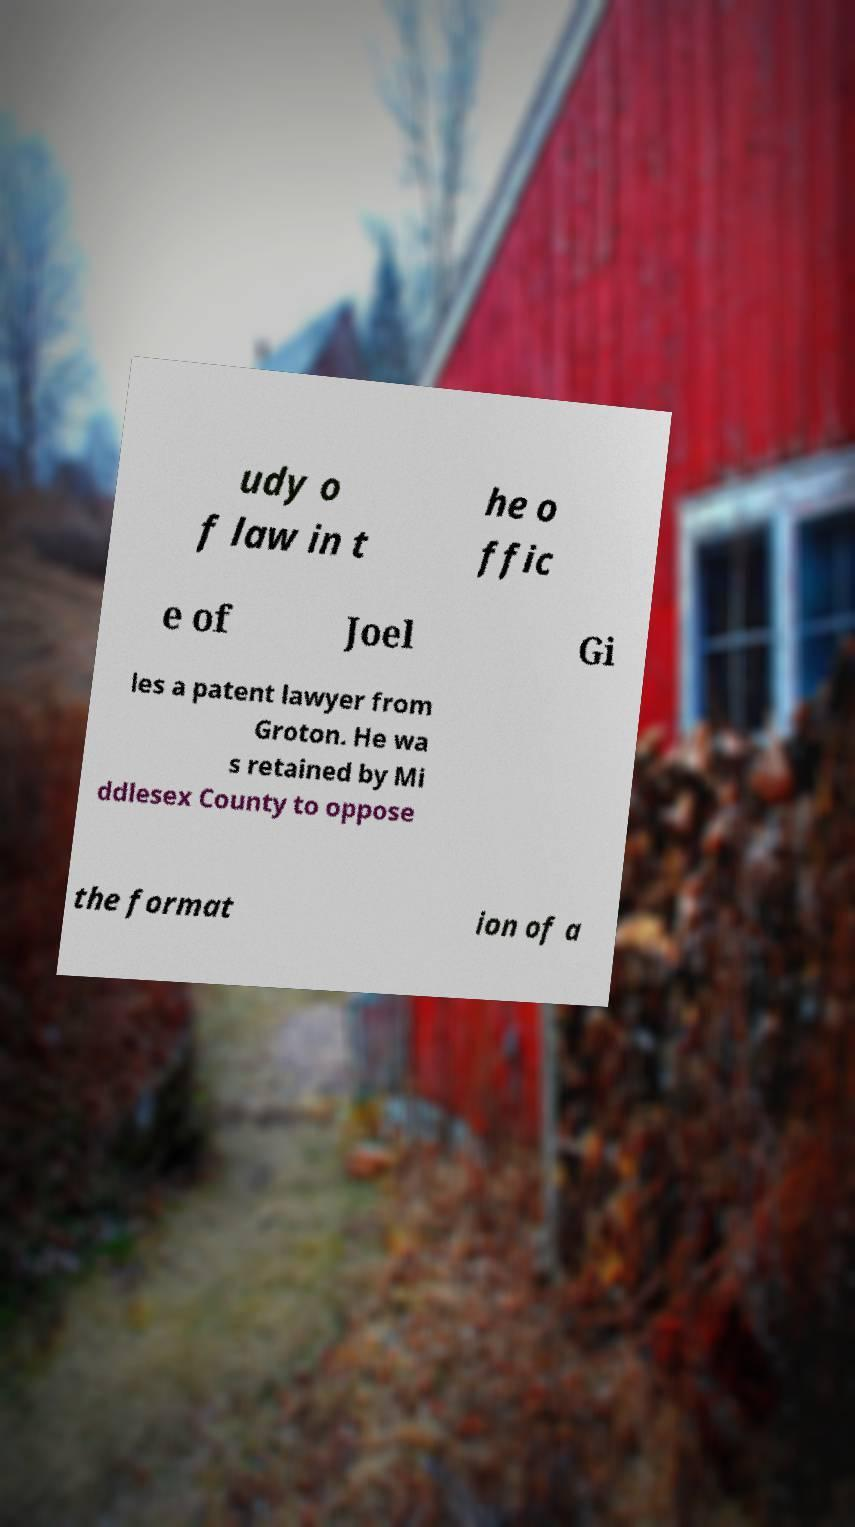For documentation purposes, I need the text within this image transcribed. Could you provide that? udy o f law in t he o ffic e of Joel Gi les a patent lawyer from Groton. He wa s retained by Mi ddlesex County to oppose the format ion of a 